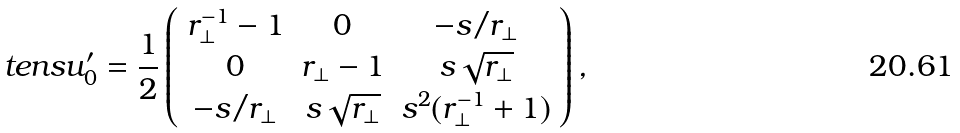<formula> <loc_0><loc_0><loc_500><loc_500>\ t e n s { u } ^ { \prime } _ { 0 } = \frac { 1 } { 2 } \left ( \begin{array} { c c c } r _ { \perp } ^ { - 1 } - 1 & 0 & - s / r _ { \perp } \\ 0 & r _ { \perp } - 1 & s \sqrt { r _ { \perp } } \\ - s / r _ { \perp } & s \sqrt { r _ { \perp } } & s ^ { 2 } ( r _ { \perp } ^ { - 1 } + 1 ) \end{array} \right ) ,</formula> 